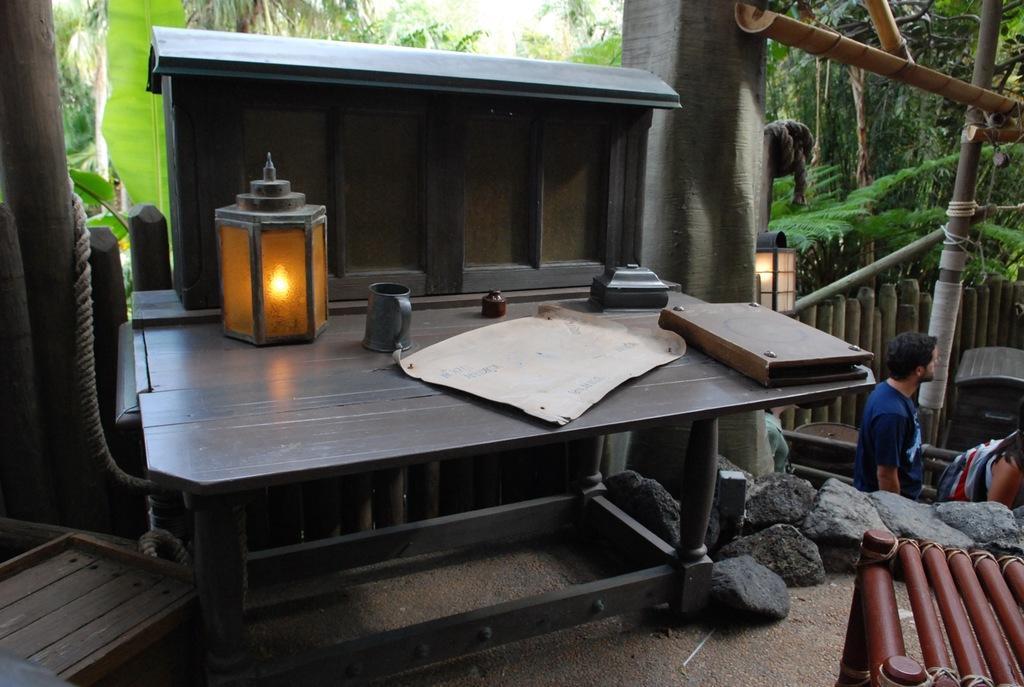In one or two sentences, can you explain what this image depicts? In this image I see a person over here and I see the light, paper and a book. In the background I see number of trees. 